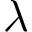Convert formula to latex. <formula><loc_0><loc_0><loc_500><loc_500>\lambda</formula> 